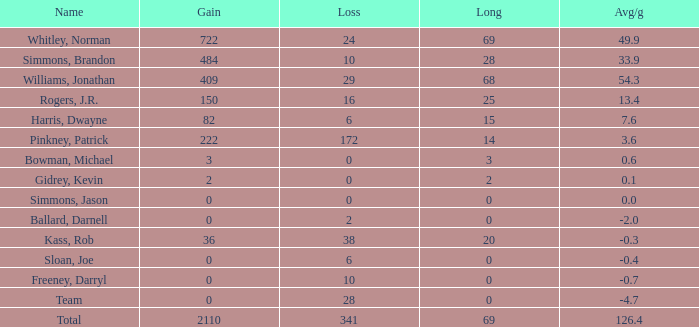What is the average Loss, when Avg/g is 0, and when Long is less than 0? None. 